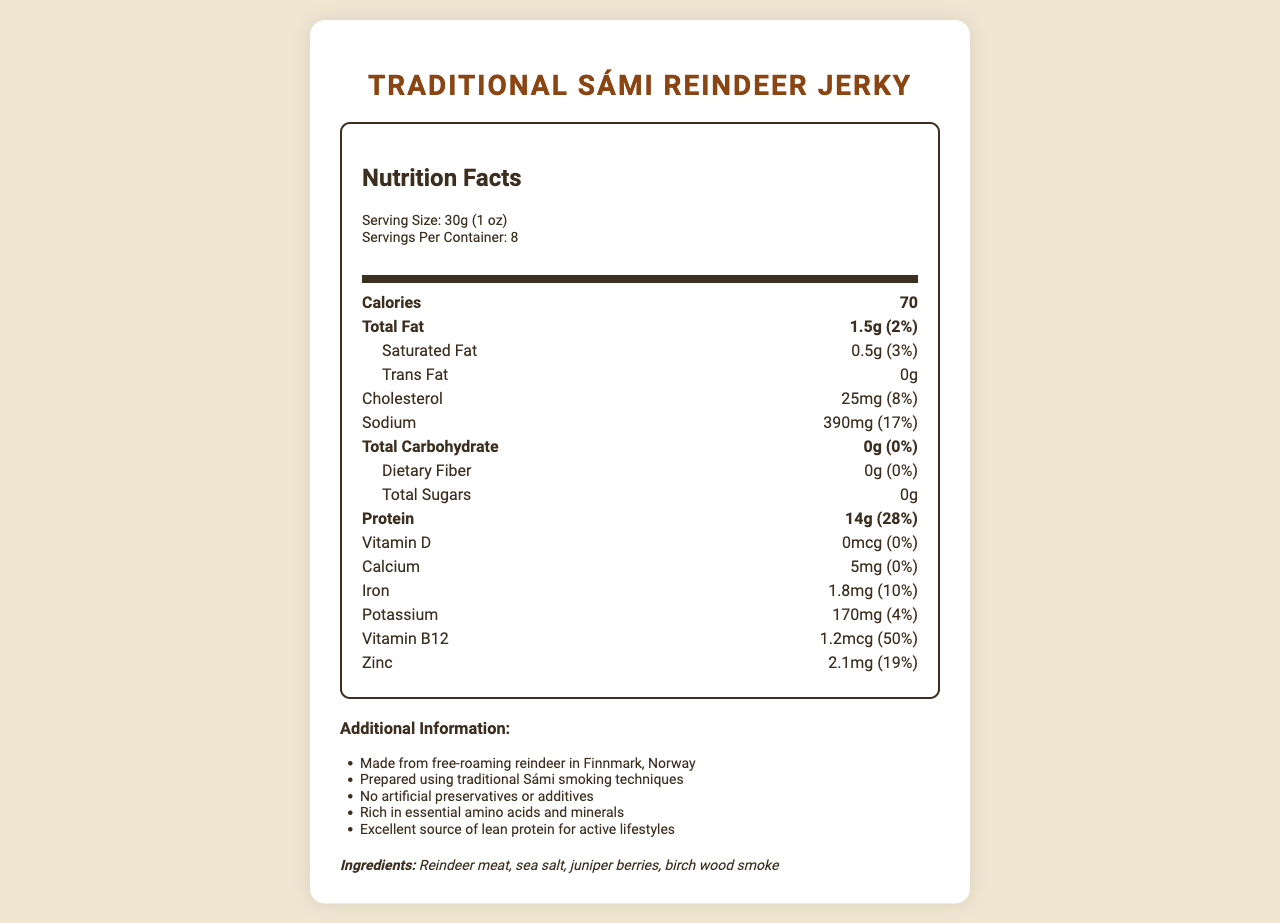How many calories are there per serving of Traditional Sámi Reindeer Jerky? The document specifies that there are 70 calories per serving of the jerky.
Answer: 70 What is the serving size of Traditional Sámi Reindeer Jerky? The document states that the serving size is 30g, which is equivalent to 1 oz.
Answer: 30g (1 oz) How many grams of total fat are present in one serving? The document mentions that one serving contains 1.5 grams of total fat.
Answer: 1.5g What is the protein content in one serving? According to the document, one serving contains 14 grams of protein.
Answer: 14g How much sodium is there in a serving? The document lists the sodium content as 390mg per serving.
Answer: 390mg Which nutrient in the Traditional Sámi Reindeer Jerky has the highest % Daily Value per serving?  
A. Sodium  
B. Cholesterol  
C. Protein  
D. Vitamin B12 The % Daily Value for Vitamin B12 is 50%, which is the highest compared to other listed nutrients.
Answer: D. Vitamin B12 What is the daily value percentage of iron per serving?  
1. 8%  
2. 10%  
3. 4%  
4. 28% The document indicates that the daily value percentage for iron is 10%.
Answer: 2. 10% Does the jerky contain any trans fat? According to the document, the trans fat content is listed as 0g.
Answer: No Is there any dietary fiber in Traditional Sámi Reindeer Jerky? The document states that the dietary fiber content is 0g.
Answer: No Summarize the main nutritional attributes of Traditional Sámi Reindeer Jerky. The explanation is a detailed description of the nutritional attributes highlighted in the document, summarizing the key points of its high protein and low-fat content, along with additional health information.
Answer: Traditional Sámi Reindeer Jerky is a high-protein, low-fat snack that contains 70 calories per serving. It has 14 grams of protein, 1.5 grams of total fat, and zero carbohydrates, sugars, and fiber. It also lacks artificial preservatives or additives and is rich in essential amino acids and minerals. Where is the reindeer meat sourced from? The document states that the reindeer meat is sourced from free-roaming reindeer in Finnmark, Norway.
Answer: Finnmark, Norway Does the jerky contain any artificial preservatives? It is mentioned in the document that the jerky contains no artificial preservatives or additives.
Answer: No What traditional technique is used to prepare the jerky? The document indicates that traditional Sámi smoking techniques are used for preparing the jerky.
Answer: Smoking What is the cholesterol content per serving? According to the document, the cholesterol content per serving is 25mg.
Answer: 25mg How much vitamin D is present in one serving of the jerky? The document lists the vitamin D content as 0mcg.
Answer: 0mcg What is the most abundant ingredient in the Traditional Sámi Reindeer Jerky? The document states that the primary ingredient is reindeer meat.
Answer: Reindeer meat What is the main flavoring ingredient used in the jerky besides reindeer meat and sea salt? Juniper berries are listed as one of the flavoring ingredients in the jerky.
Answer: Juniper berries How many servings are there in one container? The document mentions that there are 8 servings per container.
Answer: 8 What kind of wood is used for smoking the jerky? The document specifies that birch wood is used for smoking the jerky.
Answer: Birch wood Which of the following minerals is NOT listed in the nutritional information?
A. Calcium  
B. Iron  
C. Magnesium  
D. Potassium Magnesium is not mentioned in the nutritional information provided in the document.
Answer: C. Magnesium How many essential amino acids are in the jerky? The document does not specify the number of essential amino acids in the jerky.
Answer: Not enough information 